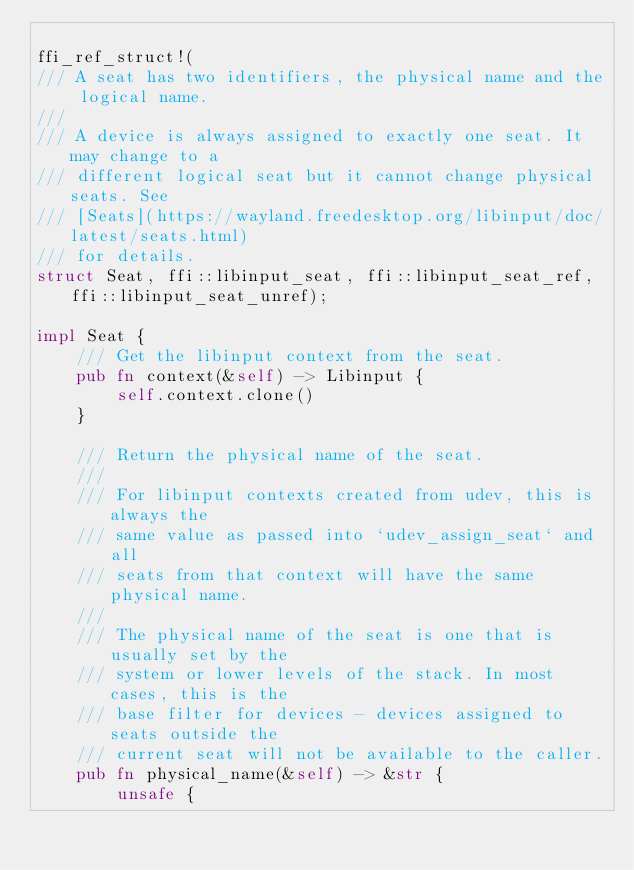<code> <loc_0><loc_0><loc_500><loc_500><_Rust_>
ffi_ref_struct!(
/// A seat has two identifiers, the physical name and the logical name.
///
/// A device is always assigned to exactly one seat. It may change to a
/// different logical seat but it cannot change physical seats. See
/// [Seats](https://wayland.freedesktop.org/libinput/doc/latest/seats.html)
/// for details.
struct Seat, ffi::libinput_seat, ffi::libinput_seat_ref, ffi::libinput_seat_unref);

impl Seat {
    /// Get the libinput context from the seat.
    pub fn context(&self) -> Libinput {
        self.context.clone()
    }

    /// Return the physical name of the seat.
    ///
    /// For libinput contexts created from udev, this is always the
    /// same value as passed into `udev_assign_seat` and all
    /// seats from that context will have the same physical name.
    ///
    /// The physical name of the seat is one that is usually set by the
    /// system or lower levels of the stack. In most cases, this is the
    /// base filter for devices - devices assigned to seats outside the
    /// current seat will not be available to the caller.
    pub fn physical_name(&self) -> &str {
        unsafe {</code> 